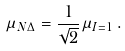<formula> <loc_0><loc_0><loc_500><loc_500>\mu _ { N \Delta } = \frac { 1 } { \sqrt { 2 } } \mu _ { I = 1 } \, .</formula> 